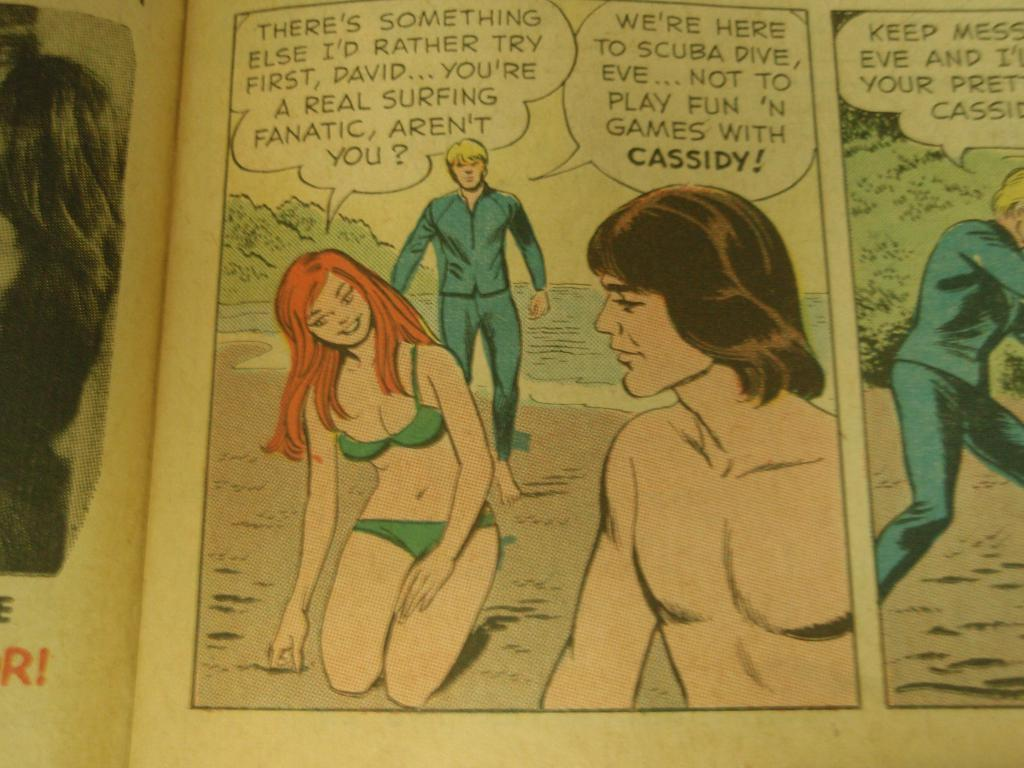<image>
Summarize the visual content of the image. Comic script about David playing games with Cassidy. 